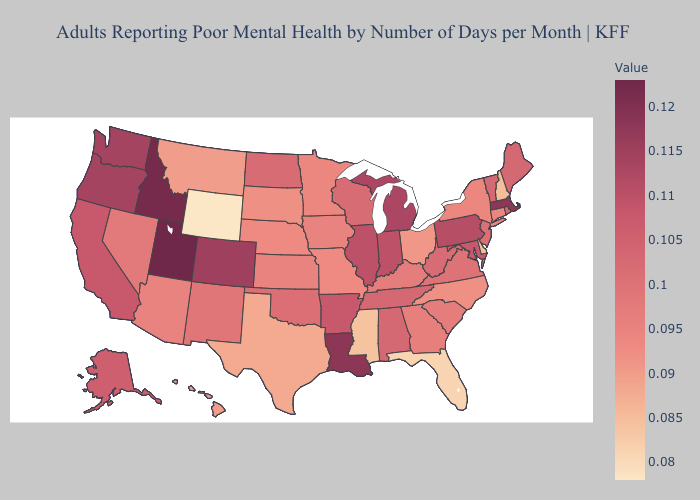Does the map have missing data?
Keep it brief. No. Does California have the lowest value in the USA?
Answer briefly. No. Does Wyoming have the lowest value in the USA?
Quick response, please. Yes. Does Oklahoma have a lower value than Nebraska?
Write a very short answer. No. Does the map have missing data?
Quick response, please. No. Among the states that border North Carolina , which have the highest value?
Concise answer only. Tennessee. Which states have the highest value in the USA?
Give a very brief answer. Utah. Among the states that border South Carolina , does North Carolina have the lowest value?
Keep it brief. Yes. 